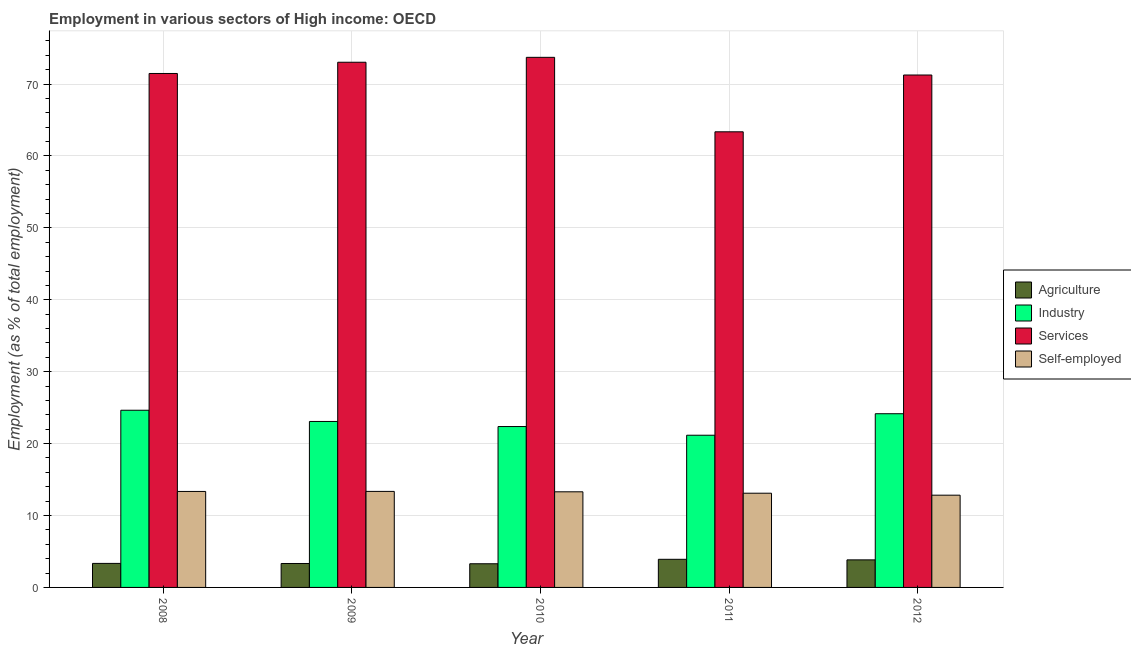How many different coloured bars are there?
Your answer should be very brief. 4. Are the number of bars on each tick of the X-axis equal?
Your response must be concise. Yes. How many bars are there on the 1st tick from the left?
Provide a short and direct response. 4. In how many cases, is the number of bars for a given year not equal to the number of legend labels?
Ensure brevity in your answer.  0. What is the percentage of self employed workers in 2010?
Provide a short and direct response. 13.3. Across all years, what is the maximum percentage of workers in agriculture?
Give a very brief answer. 3.91. Across all years, what is the minimum percentage of workers in agriculture?
Your response must be concise. 3.29. In which year was the percentage of workers in services maximum?
Provide a succinct answer. 2010. What is the total percentage of self employed workers in the graph?
Provide a short and direct response. 65.93. What is the difference between the percentage of workers in agriculture in 2011 and that in 2012?
Provide a short and direct response. 0.08. What is the difference between the percentage of workers in industry in 2010 and the percentage of workers in agriculture in 2009?
Offer a terse response. -0.71. What is the average percentage of workers in services per year?
Offer a very short reply. 70.57. In how many years, is the percentage of self employed workers greater than 2 %?
Provide a short and direct response. 5. What is the ratio of the percentage of workers in agriculture in 2008 to that in 2009?
Offer a terse response. 1. What is the difference between the highest and the second highest percentage of self employed workers?
Make the answer very short. 0.01. What is the difference between the highest and the lowest percentage of workers in industry?
Offer a terse response. 3.48. Is the sum of the percentage of workers in agriculture in 2008 and 2012 greater than the maximum percentage of workers in industry across all years?
Your response must be concise. Yes. Is it the case that in every year, the sum of the percentage of self employed workers and percentage of workers in services is greater than the sum of percentage of workers in industry and percentage of workers in agriculture?
Provide a succinct answer. Yes. What does the 2nd bar from the left in 2008 represents?
Offer a very short reply. Industry. What does the 1st bar from the right in 2011 represents?
Provide a short and direct response. Self-employed. Is it the case that in every year, the sum of the percentage of workers in agriculture and percentage of workers in industry is greater than the percentage of workers in services?
Provide a short and direct response. No. How many bars are there?
Your answer should be very brief. 20. Are all the bars in the graph horizontal?
Make the answer very short. No. What is the difference between two consecutive major ticks on the Y-axis?
Give a very brief answer. 10. Are the values on the major ticks of Y-axis written in scientific E-notation?
Provide a succinct answer. No. Does the graph contain any zero values?
Your answer should be very brief. No. Does the graph contain grids?
Provide a short and direct response. Yes. Where does the legend appear in the graph?
Offer a terse response. Center right. What is the title of the graph?
Keep it short and to the point. Employment in various sectors of High income: OECD. What is the label or title of the Y-axis?
Offer a terse response. Employment (as % of total employment). What is the Employment (as % of total employment) in Agriculture in 2008?
Provide a short and direct response. 3.34. What is the Employment (as % of total employment) in Industry in 2008?
Offer a very short reply. 24.64. What is the Employment (as % of total employment) of Services in 2008?
Offer a very short reply. 71.47. What is the Employment (as % of total employment) in Self-employed in 2008?
Your response must be concise. 13.35. What is the Employment (as % of total employment) in Agriculture in 2009?
Keep it short and to the point. 3.33. What is the Employment (as % of total employment) of Industry in 2009?
Ensure brevity in your answer.  23.08. What is the Employment (as % of total employment) in Services in 2009?
Your response must be concise. 73.03. What is the Employment (as % of total employment) of Self-employed in 2009?
Make the answer very short. 13.35. What is the Employment (as % of total employment) of Agriculture in 2010?
Your answer should be very brief. 3.29. What is the Employment (as % of total employment) of Industry in 2010?
Provide a succinct answer. 22.37. What is the Employment (as % of total employment) of Services in 2010?
Provide a short and direct response. 73.72. What is the Employment (as % of total employment) of Self-employed in 2010?
Keep it short and to the point. 13.3. What is the Employment (as % of total employment) in Agriculture in 2011?
Your answer should be compact. 3.91. What is the Employment (as % of total employment) in Industry in 2011?
Your response must be concise. 21.17. What is the Employment (as % of total employment) in Services in 2011?
Keep it short and to the point. 63.36. What is the Employment (as % of total employment) in Self-employed in 2011?
Offer a very short reply. 13.1. What is the Employment (as % of total employment) of Agriculture in 2012?
Provide a succinct answer. 3.83. What is the Employment (as % of total employment) in Industry in 2012?
Offer a terse response. 24.16. What is the Employment (as % of total employment) of Services in 2012?
Offer a terse response. 71.26. What is the Employment (as % of total employment) in Self-employed in 2012?
Provide a short and direct response. 12.83. Across all years, what is the maximum Employment (as % of total employment) in Agriculture?
Keep it short and to the point. 3.91. Across all years, what is the maximum Employment (as % of total employment) in Industry?
Provide a short and direct response. 24.64. Across all years, what is the maximum Employment (as % of total employment) of Services?
Give a very brief answer. 73.72. Across all years, what is the maximum Employment (as % of total employment) in Self-employed?
Make the answer very short. 13.35. Across all years, what is the minimum Employment (as % of total employment) of Agriculture?
Give a very brief answer. 3.29. Across all years, what is the minimum Employment (as % of total employment) of Industry?
Make the answer very short. 21.17. Across all years, what is the minimum Employment (as % of total employment) in Services?
Provide a succinct answer. 63.36. Across all years, what is the minimum Employment (as % of total employment) of Self-employed?
Offer a terse response. 12.83. What is the total Employment (as % of total employment) in Agriculture in the graph?
Your response must be concise. 17.7. What is the total Employment (as % of total employment) in Industry in the graph?
Give a very brief answer. 115.42. What is the total Employment (as % of total employment) of Services in the graph?
Your response must be concise. 352.85. What is the total Employment (as % of total employment) in Self-employed in the graph?
Offer a very short reply. 65.93. What is the difference between the Employment (as % of total employment) in Agriculture in 2008 and that in 2009?
Provide a succinct answer. 0.01. What is the difference between the Employment (as % of total employment) of Industry in 2008 and that in 2009?
Your answer should be compact. 1.56. What is the difference between the Employment (as % of total employment) in Services in 2008 and that in 2009?
Give a very brief answer. -1.56. What is the difference between the Employment (as % of total employment) in Self-employed in 2008 and that in 2009?
Provide a short and direct response. -0.01. What is the difference between the Employment (as % of total employment) of Agriculture in 2008 and that in 2010?
Make the answer very short. 0.05. What is the difference between the Employment (as % of total employment) in Industry in 2008 and that in 2010?
Offer a terse response. 2.27. What is the difference between the Employment (as % of total employment) of Services in 2008 and that in 2010?
Offer a terse response. -2.25. What is the difference between the Employment (as % of total employment) of Self-employed in 2008 and that in 2010?
Ensure brevity in your answer.  0.05. What is the difference between the Employment (as % of total employment) in Agriculture in 2008 and that in 2011?
Ensure brevity in your answer.  -0.57. What is the difference between the Employment (as % of total employment) of Industry in 2008 and that in 2011?
Offer a terse response. 3.48. What is the difference between the Employment (as % of total employment) of Services in 2008 and that in 2011?
Offer a terse response. 8.11. What is the difference between the Employment (as % of total employment) in Self-employed in 2008 and that in 2011?
Your answer should be very brief. 0.25. What is the difference between the Employment (as % of total employment) in Agriculture in 2008 and that in 2012?
Your response must be concise. -0.49. What is the difference between the Employment (as % of total employment) in Industry in 2008 and that in 2012?
Offer a terse response. 0.49. What is the difference between the Employment (as % of total employment) in Services in 2008 and that in 2012?
Offer a terse response. 0.21. What is the difference between the Employment (as % of total employment) in Self-employed in 2008 and that in 2012?
Your response must be concise. 0.52. What is the difference between the Employment (as % of total employment) of Agriculture in 2009 and that in 2010?
Offer a terse response. 0.04. What is the difference between the Employment (as % of total employment) of Industry in 2009 and that in 2010?
Provide a short and direct response. 0.71. What is the difference between the Employment (as % of total employment) of Services in 2009 and that in 2010?
Keep it short and to the point. -0.68. What is the difference between the Employment (as % of total employment) in Self-employed in 2009 and that in 2010?
Keep it short and to the point. 0.06. What is the difference between the Employment (as % of total employment) in Agriculture in 2009 and that in 2011?
Provide a succinct answer. -0.58. What is the difference between the Employment (as % of total employment) of Industry in 2009 and that in 2011?
Provide a short and direct response. 1.91. What is the difference between the Employment (as % of total employment) in Services in 2009 and that in 2011?
Provide a succinct answer. 9.67. What is the difference between the Employment (as % of total employment) in Self-employed in 2009 and that in 2011?
Offer a terse response. 0.25. What is the difference between the Employment (as % of total employment) in Agriculture in 2009 and that in 2012?
Offer a very short reply. -0.5. What is the difference between the Employment (as % of total employment) of Industry in 2009 and that in 2012?
Provide a short and direct response. -1.08. What is the difference between the Employment (as % of total employment) in Services in 2009 and that in 2012?
Offer a terse response. 1.77. What is the difference between the Employment (as % of total employment) of Self-employed in 2009 and that in 2012?
Ensure brevity in your answer.  0.52. What is the difference between the Employment (as % of total employment) in Agriculture in 2010 and that in 2011?
Make the answer very short. -0.62. What is the difference between the Employment (as % of total employment) in Industry in 2010 and that in 2011?
Offer a very short reply. 1.21. What is the difference between the Employment (as % of total employment) in Services in 2010 and that in 2011?
Keep it short and to the point. 10.36. What is the difference between the Employment (as % of total employment) of Self-employed in 2010 and that in 2011?
Your answer should be compact. 0.2. What is the difference between the Employment (as % of total employment) in Agriculture in 2010 and that in 2012?
Provide a short and direct response. -0.54. What is the difference between the Employment (as % of total employment) in Industry in 2010 and that in 2012?
Provide a succinct answer. -1.78. What is the difference between the Employment (as % of total employment) of Services in 2010 and that in 2012?
Your answer should be very brief. 2.46. What is the difference between the Employment (as % of total employment) in Self-employed in 2010 and that in 2012?
Provide a short and direct response. 0.47. What is the difference between the Employment (as % of total employment) of Agriculture in 2011 and that in 2012?
Your response must be concise. 0.08. What is the difference between the Employment (as % of total employment) of Industry in 2011 and that in 2012?
Offer a very short reply. -2.99. What is the difference between the Employment (as % of total employment) of Services in 2011 and that in 2012?
Give a very brief answer. -7.9. What is the difference between the Employment (as % of total employment) in Self-employed in 2011 and that in 2012?
Provide a succinct answer. 0.27. What is the difference between the Employment (as % of total employment) of Agriculture in 2008 and the Employment (as % of total employment) of Industry in 2009?
Keep it short and to the point. -19.74. What is the difference between the Employment (as % of total employment) in Agriculture in 2008 and the Employment (as % of total employment) in Services in 2009?
Your response must be concise. -69.69. What is the difference between the Employment (as % of total employment) of Agriculture in 2008 and the Employment (as % of total employment) of Self-employed in 2009?
Offer a terse response. -10.01. What is the difference between the Employment (as % of total employment) of Industry in 2008 and the Employment (as % of total employment) of Services in 2009?
Your response must be concise. -48.39. What is the difference between the Employment (as % of total employment) in Industry in 2008 and the Employment (as % of total employment) in Self-employed in 2009?
Offer a very short reply. 11.29. What is the difference between the Employment (as % of total employment) in Services in 2008 and the Employment (as % of total employment) in Self-employed in 2009?
Provide a succinct answer. 58.12. What is the difference between the Employment (as % of total employment) of Agriculture in 2008 and the Employment (as % of total employment) of Industry in 2010?
Provide a succinct answer. -19.03. What is the difference between the Employment (as % of total employment) of Agriculture in 2008 and the Employment (as % of total employment) of Services in 2010?
Ensure brevity in your answer.  -70.38. What is the difference between the Employment (as % of total employment) of Agriculture in 2008 and the Employment (as % of total employment) of Self-employed in 2010?
Keep it short and to the point. -9.96. What is the difference between the Employment (as % of total employment) of Industry in 2008 and the Employment (as % of total employment) of Services in 2010?
Your response must be concise. -49.08. What is the difference between the Employment (as % of total employment) in Industry in 2008 and the Employment (as % of total employment) in Self-employed in 2010?
Your answer should be very brief. 11.34. What is the difference between the Employment (as % of total employment) of Services in 2008 and the Employment (as % of total employment) of Self-employed in 2010?
Keep it short and to the point. 58.17. What is the difference between the Employment (as % of total employment) in Agriculture in 2008 and the Employment (as % of total employment) in Industry in 2011?
Provide a short and direct response. -17.83. What is the difference between the Employment (as % of total employment) of Agriculture in 2008 and the Employment (as % of total employment) of Services in 2011?
Provide a short and direct response. -60.02. What is the difference between the Employment (as % of total employment) of Agriculture in 2008 and the Employment (as % of total employment) of Self-employed in 2011?
Give a very brief answer. -9.76. What is the difference between the Employment (as % of total employment) of Industry in 2008 and the Employment (as % of total employment) of Services in 2011?
Offer a terse response. -38.72. What is the difference between the Employment (as % of total employment) of Industry in 2008 and the Employment (as % of total employment) of Self-employed in 2011?
Your answer should be very brief. 11.54. What is the difference between the Employment (as % of total employment) of Services in 2008 and the Employment (as % of total employment) of Self-employed in 2011?
Offer a terse response. 58.37. What is the difference between the Employment (as % of total employment) of Agriculture in 2008 and the Employment (as % of total employment) of Industry in 2012?
Make the answer very short. -20.82. What is the difference between the Employment (as % of total employment) in Agriculture in 2008 and the Employment (as % of total employment) in Services in 2012?
Your response must be concise. -67.92. What is the difference between the Employment (as % of total employment) in Agriculture in 2008 and the Employment (as % of total employment) in Self-employed in 2012?
Provide a succinct answer. -9.49. What is the difference between the Employment (as % of total employment) of Industry in 2008 and the Employment (as % of total employment) of Services in 2012?
Provide a short and direct response. -46.62. What is the difference between the Employment (as % of total employment) in Industry in 2008 and the Employment (as % of total employment) in Self-employed in 2012?
Your answer should be very brief. 11.81. What is the difference between the Employment (as % of total employment) of Services in 2008 and the Employment (as % of total employment) of Self-employed in 2012?
Your answer should be compact. 58.64. What is the difference between the Employment (as % of total employment) of Agriculture in 2009 and the Employment (as % of total employment) of Industry in 2010?
Provide a succinct answer. -19.05. What is the difference between the Employment (as % of total employment) of Agriculture in 2009 and the Employment (as % of total employment) of Services in 2010?
Give a very brief answer. -70.39. What is the difference between the Employment (as % of total employment) in Agriculture in 2009 and the Employment (as % of total employment) in Self-employed in 2010?
Keep it short and to the point. -9.97. What is the difference between the Employment (as % of total employment) in Industry in 2009 and the Employment (as % of total employment) in Services in 2010?
Offer a very short reply. -50.64. What is the difference between the Employment (as % of total employment) of Industry in 2009 and the Employment (as % of total employment) of Self-employed in 2010?
Provide a short and direct response. 9.78. What is the difference between the Employment (as % of total employment) of Services in 2009 and the Employment (as % of total employment) of Self-employed in 2010?
Provide a short and direct response. 59.74. What is the difference between the Employment (as % of total employment) of Agriculture in 2009 and the Employment (as % of total employment) of Industry in 2011?
Offer a very short reply. -17.84. What is the difference between the Employment (as % of total employment) in Agriculture in 2009 and the Employment (as % of total employment) in Services in 2011?
Your answer should be compact. -60.03. What is the difference between the Employment (as % of total employment) of Agriculture in 2009 and the Employment (as % of total employment) of Self-employed in 2011?
Ensure brevity in your answer.  -9.77. What is the difference between the Employment (as % of total employment) of Industry in 2009 and the Employment (as % of total employment) of Services in 2011?
Your answer should be very brief. -40.28. What is the difference between the Employment (as % of total employment) of Industry in 2009 and the Employment (as % of total employment) of Self-employed in 2011?
Offer a very short reply. 9.98. What is the difference between the Employment (as % of total employment) of Services in 2009 and the Employment (as % of total employment) of Self-employed in 2011?
Offer a terse response. 59.93. What is the difference between the Employment (as % of total employment) of Agriculture in 2009 and the Employment (as % of total employment) of Industry in 2012?
Provide a succinct answer. -20.83. What is the difference between the Employment (as % of total employment) in Agriculture in 2009 and the Employment (as % of total employment) in Services in 2012?
Make the answer very short. -67.93. What is the difference between the Employment (as % of total employment) of Agriculture in 2009 and the Employment (as % of total employment) of Self-employed in 2012?
Your answer should be very brief. -9.5. What is the difference between the Employment (as % of total employment) in Industry in 2009 and the Employment (as % of total employment) in Services in 2012?
Ensure brevity in your answer.  -48.18. What is the difference between the Employment (as % of total employment) of Industry in 2009 and the Employment (as % of total employment) of Self-employed in 2012?
Make the answer very short. 10.25. What is the difference between the Employment (as % of total employment) of Services in 2009 and the Employment (as % of total employment) of Self-employed in 2012?
Give a very brief answer. 60.21. What is the difference between the Employment (as % of total employment) of Agriculture in 2010 and the Employment (as % of total employment) of Industry in 2011?
Ensure brevity in your answer.  -17.87. What is the difference between the Employment (as % of total employment) of Agriculture in 2010 and the Employment (as % of total employment) of Services in 2011?
Offer a terse response. -60.07. What is the difference between the Employment (as % of total employment) of Agriculture in 2010 and the Employment (as % of total employment) of Self-employed in 2011?
Make the answer very short. -9.81. What is the difference between the Employment (as % of total employment) of Industry in 2010 and the Employment (as % of total employment) of Services in 2011?
Give a very brief answer. -40.99. What is the difference between the Employment (as % of total employment) of Industry in 2010 and the Employment (as % of total employment) of Self-employed in 2011?
Make the answer very short. 9.27. What is the difference between the Employment (as % of total employment) of Services in 2010 and the Employment (as % of total employment) of Self-employed in 2011?
Your response must be concise. 60.62. What is the difference between the Employment (as % of total employment) in Agriculture in 2010 and the Employment (as % of total employment) in Industry in 2012?
Offer a very short reply. -20.86. What is the difference between the Employment (as % of total employment) of Agriculture in 2010 and the Employment (as % of total employment) of Services in 2012?
Offer a very short reply. -67.97. What is the difference between the Employment (as % of total employment) in Agriculture in 2010 and the Employment (as % of total employment) in Self-employed in 2012?
Provide a succinct answer. -9.54. What is the difference between the Employment (as % of total employment) in Industry in 2010 and the Employment (as % of total employment) in Services in 2012?
Your answer should be compact. -48.89. What is the difference between the Employment (as % of total employment) in Industry in 2010 and the Employment (as % of total employment) in Self-employed in 2012?
Your answer should be compact. 9.54. What is the difference between the Employment (as % of total employment) of Services in 2010 and the Employment (as % of total employment) of Self-employed in 2012?
Provide a short and direct response. 60.89. What is the difference between the Employment (as % of total employment) in Agriculture in 2011 and the Employment (as % of total employment) in Industry in 2012?
Make the answer very short. -20.24. What is the difference between the Employment (as % of total employment) of Agriculture in 2011 and the Employment (as % of total employment) of Services in 2012?
Make the answer very short. -67.35. What is the difference between the Employment (as % of total employment) in Agriculture in 2011 and the Employment (as % of total employment) in Self-employed in 2012?
Your response must be concise. -8.92. What is the difference between the Employment (as % of total employment) in Industry in 2011 and the Employment (as % of total employment) in Services in 2012?
Provide a succinct answer. -50.09. What is the difference between the Employment (as % of total employment) in Industry in 2011 and the Employment (as % of total employment) in Self-employed in 2012?
Give a very brief answer. 8.34. What is the difference between the Employment (as % of total employment) in Services in 2011 and the Employment (as % of total employment) in Self-employed in 2012?
Provide a short and direct response. 50.53. What is the average Employment (as % of total employment) in Agriculture per year?
Make the answer very short. 3.54. What is the average Employment (as % of total employment) in Industry per year?
Provide a succinct answer. 23.08. What is the average Employment (as % of total employment) of Services per year?
Your answer should be compact. 70.57. What is the average Employment (as % of total employment) in Self-employed per year?
Ensure brevity in your answer.  13.19. In the year 2008, what is the difference between the Employment (as % of total employment) of Agriculture and Employment (as % of total employment) of Industry?
Your answer should be very brief. -21.3. In the year 2008, what is the difference between the Employment (as % of total employment) in Agriculture and Employment (as % of total employment) in Services?
Make the answer very short. -68.13. In the year 2008, what is the difference between the Employment (as % of total employment) of Agriculture and Employment (as % of total employment) of Self-employed?
Ensure brevity in your answer.  -10.01. In the year 2008, what is the difference between the Employment (as % of total employment) in Industry and Employment (as % of total employment) in Services?
Your response must be concise. -46.83. In the year 2008, what is the difference between the Employment (as % of total employment) in Industry and Employment (as % of total employment) in Self-employed?
Provide a succinct answer. 11.29. In the year 2008, what is the difference between the Employment (as % of total employment) in Services and Employment (as % of total employment) in Self-employed?
Keep it short and to the point. 58.12. In the year 2009, what is the difference between the Employment (as % of total employment) in Agriculture and Employment (as % of total employment) in Industry?
Offer a terse response. -19.75. In the year 2009, what is the difference between the Employment (as % of total employment) of Agriculture and Employment (as % of total employment) of Services?
Your response must be concise. -69.71. In the year 2009, what is the difference between the Employment (as % of total employment) of Agriculture and Employment (as % of total employment) of Self-employed?
Give a very brief answer. -10.03. In the year 2009, what is the difference between the Employment (as % of total employment) in Industry and Employment (as % of total employment) in Services?
Your answer should be compact. -49.95. In the year 2009, what is the difference between the Employment (as % of total employment) of Industry and Employment (as % of total employment) of Self-employed?
Offer a very short reply. 9.73. In the year 2009, what is the difference between the Employment (as % of total employment) of Services and Employment (as % of total employment) of Self-employed?
Provide a succinct answer. 59.68. In the year 2010, what is the difference between the Employment (as % of total employment) in Agriculture and Employment (as % of total employment) in Industry?
Ensure brevity in your answer.  -19.08. In the year 2010, what is the difference between the Employment (as % of total employment) in Agriculture and Employment (as % of total employment) in Services?
Your answer should be very brief. -70.43. In the year 2010, what is the difference between the Employment (as % of total employment) of Agriculture and Employment (as % of total employment) of Self-employed?
Your answer should be compact. -10.01. In the year 2010, what is the difference between the Employment (as % of total employment) of Industry and Employment (as % of total employment) of Services?
Make the answer very short. -51.34. In the year 2010, what is the difference between the Employment (as % of total employment) in Industry and Employment (as % of total employment) in Self-employed?
Provide a short and direct response. 9.08. In the year 2010, what is the difference between the Employment (as % of total employment) of Services and Employment (as % of total employment) of Self-employed?
Your answer should be very brief. 60.42. In the year 2011, what is the difference between the Employment (as % of total employment) of Agriculture and Employment (as % of total employment) of Industry?
Provide a succinct answer. -17.25. In the year 2011, what is the difference between the Employment (as % of total employment) in Agriculture and Employment (as % of total employment) in Services?
Provide a short and direct response. -59.45. In the year 2011, what is the difference between the Employment (as % of total employment) in Agriculture and Employment (as % of total employment) in Self-employed?
Give a very brief answer. -9.19. In the year 2011, what is the difference between the Employment (as % of total employment) in Industry and Employment (as % of total employment) in Services?
Provide a short and direct response. -42.2. In the year 2011, what is the difference between the Employment (as % of total employment) of Industry and Employment (as % of total employment) of Self-employed?
Your response must be concise. 8.06. In the year 2011, what is the difference between the Employment (as % of total employment) of Services and Employment (as % of total employment) of Self-employed?
Offer a very short reply. 50.26. In the year 2012, what is the difference between the Employment (as % of total employment) in Agriculture and Employment (as % of total employment) in Industry?
Make the answer very short. -20.32. In the year 2012, what is the difference between the Employment (as % of total employment) of Agriculture and Employment (as % of total employment) of Services?
Provide a short and direct response. -67.43. In the year 2012, what is the difference between the Employment (as % of total employment) in Agriculture and Employment (as % of total employment) in Self-employed?
Ensure brevity in your answer.  -9. In the year 2012, what is the difference between the Employment (as % of total employment) in Industry and Employment (as % of total employment) in Services?
Give a very brief answer. -47.1. In the year 2012, what is the difference between the Employment (as % of total employment) of Industry and Employment (as % of total employment) of Self-employed?
Your answer should be very brief. 11.33. In the year 2012, what is the difference between the Employment (as % of total employment) in Services and Employment (as % of total employment) in Self-employed?
Keep it short and to the point. 58.43. What is the ratio of the Employment (as % of total employment) of Agriculture in 2008 to that in 2009?
Offer a very short reply. 1. What is the ratio of the Employment (as % of total employment) in Industry in 2008 to that in 2009?
Make the answer very short. 1.07. What is the ratio of the Employment (as % of total employment) in Services in 2008 to that in 2009?
Offer a very short reply. 0.98. What is the ratio of the Employment (as % of total employment) in Self-employed in 2008 to that in 2009?
Give a very brief answer. 1. What is the ratio of the Employment (as % of total employment) of Agriculture in 2008 to that in 2010?
Provide a succinct answer. 1.01. What is the ratio of the Employment (as % of total employment) of Industry in 2008 to that in 2010?
Ensure brevity in your answer.  1.1. What is the ratio of the Employment (as % of total employment) of Services in 2008 to that in 2010?
Offer a terse response. 0.97. What is the ratio of the Employment (as % of total employment) in Agriculture in 2008 to that in 2011?
Provide a succinct answer. 0.85. What is the ratio of the Employment (as % of total employment) of Industry in 2008 to that in 2011?
Your answer should be compact. 1.16. What is the ratio of the Employment (as % of total employment) in Services in 2008 to that in 2011?
Offer a terse response. 1.13. What is the ratio of the Employment (as % of total employment) in Self-employed in 2008 to that in 2011?
Offer a terse response. 1.02. What is the ratio of the Employment (as % of total employment) of Agriculture in 2008 to that in 2012?
Provide a succinct answer. 0.87. What is the ratio of the Employment (as % of total employment) of Industry in 2008 to that in 2012?
Provide a succinct answer. 1.02. What is the ratio of the Employment (as % of total employment) in Services in 2008 to that in 2012?
Provide a short and direct response. 1. What is the ratio of the Employment (as % of total employment) in Self-employed in 2008 to that in 2012?
Make the answer very short. 1.04. What is the ratio of the Employment (as % of total employment) in Agriculture in 2009 to that in 2010?
Give a very brief answer. 1.01. What is the ratio of the Employment (as % of total employment) in Industry in 2009 to that in 2010?
Provide a succinct answer. 1.03. What is the ratio of the Employment (as % of total employment) of Self-employed in 2009 to that in 2010?
Give a very brief answer. 1. What is the ratio of the Employment (as % of total employment) of Agriculture in 2009 to that in 2011?
Offer a very short reply. 0.85. What is the ratio of the Employment (as % of total employment) in Industry in 2009 to that in 2011?
Make the answer very short. 1.09. What is the ratio of the Employment (as % of total employment) in Services in 2009 to that in 2011?
Keep it short and to the point. 1.15. What is the ratio of the Employment (as % of total employment) in Self-employed in 2009 to that in 2011?
Give a very brief answer. 1.02. What is the ratio of the Employment (as % of total employment) in Agriculture in 2009 to that in 2012?
Ensure brevity in your answer.  0.87. What is the ratio of the Employment (as % of total employment) of Industry in 2009 to that in 2012?
Give a very brief answer. 0.96. What is the ratio of the Employment (as % of total employment) of Services in 2009 to that in 2012?
Provide a succinct answer. 1.02. What is the ratio of the Employment (as % of total employment) of Self-employed in 2009 to that in 2012?
Your answer should be very brief. 1.04. What is the ratio of the Employment (as % of total employment) of Agriculture in 2010 to that in 2011?
Make the answer very short. 0.84. What is the ratio of the Employment (as % of total employment) of Industry in 2010 to that in 2011?
Your answer should be very brief. 1.06. What is the ratio of the Employment (as % of total employment) of Services in 2010 to that in 2011?
Your answer should be compact. 1.16. What is the ratio of the Employment (as % of total employment) in Self-employed in 2010 to that in 2011?
Offer a terse response. 1.01. What is the ratio of the Employment (as % of total employment) in Agriculture in 2010 to that in 2012?
Make the answer very short. 0.86. What is the ratio of the Employment (as % of total employment) of Industry in 2010 to that in 2012?
Provide a short and direct response. 0.93. What is the ratio of the Employment (as % of total employment) in Services in 2010 to that in 2012?
Offer a very short reply. 1.03. What is the ratio of the Employment (as % of total employment) in Self-employed in 2010 to that in 2012?
Offer a very short reply. 1.04. What is the ratio of the Employment (as % of total employment) in Agriculture in 2011 to that in 2012?
Your answer should be very brief. 1.02. What is the ratio of the Employment (as % of total employment) of Industry in 2011 to that in 2012?
Keep it short and to the point. 0.88. What is the ratio of the Employment (as % of total employment) in Services in 2011 to that in 2012?
Offer a terse response. 0.89. What is the ratio of the Employment (as % of total employment) in Self-employed in 2011 to that in 2012?
Your response must be concise. 1.02. What is the difference between the highest and the second highest Employment (as % of total employment) of Agriculture?
Provide a short and direct response. 0.08. What is the difference between the highest and the second highest Employment (as % of total employment) in Industry?
Provide a short and direct response. 0.49. What is the difference between the highest and the second highest Employment (as % of total employment) of Services?
Offer a terse response. 0.68. What is the difference between the highest and the second highest Employment (as % of total employment) in Self-employed?
Offer a very short reply. 0.01. What is the difference between the highest and the lowest Employment (as % of total employment) of Agriculture?
Provide a short and direct response. 0.62. What is the difference between the highest and the lowest Employment (as % of total employment) in Industry?
Offer a terse response. 3.48. What is the difference between the highest and the lowest Employment (as % of total employment) in Services?
Your answer should be very brief. 10.36. What is the difference between the highest and the lowest Employment (as % of total employment) in Self-employed?
Make the answer very short. 0.52. 